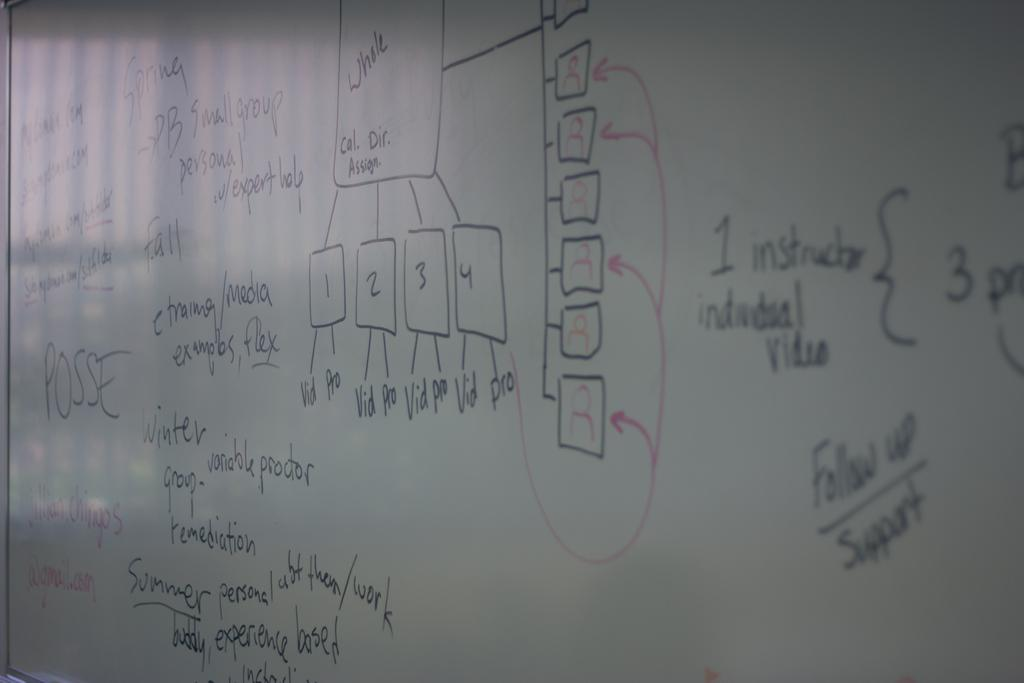What is the main object in the image? There is a white color board in the image. What is written or displayed on the board? There is text and numbers on the board. How does the game on the board move around in the image? There is no game present on the board in the image. 